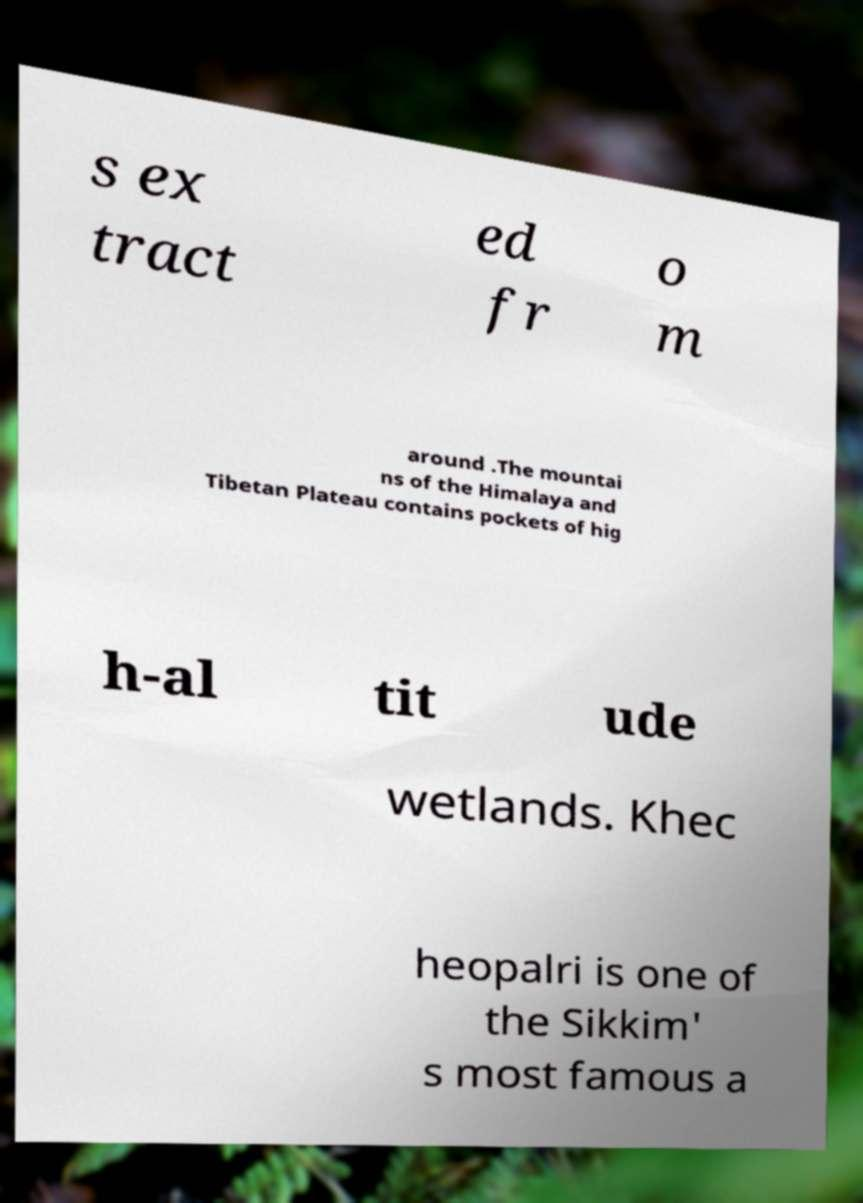Could you assist in decoding the text presented in this image and type it out clearly? s ex tract ed fr o m around .The mountai ns of the Himalaya and Tibetan Plateau contains pockets of hig h-al tit ude wetlands. Khec heopalri is one of the Sikkim' s most famous a 